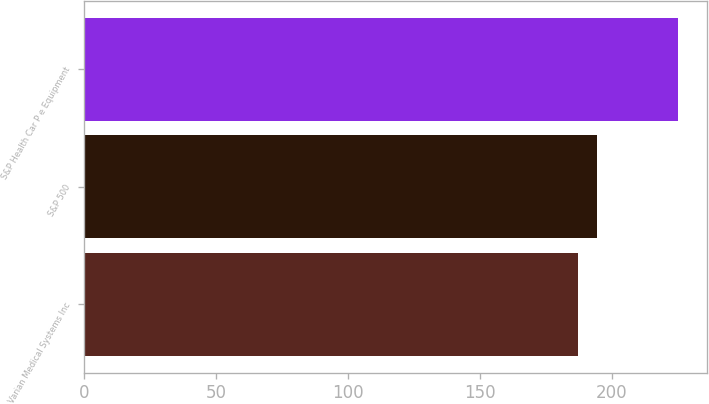<chart> <loc_0><loc_0><loc_500><loc_500><bar_chart><fcel>Varian Medical Systems Inc<fcel>S&P 500<fcel>S&P Health Car P e Equipment<nl><fcel>187.32<fcel>194.44<fcel>224.92<nl></chart> 